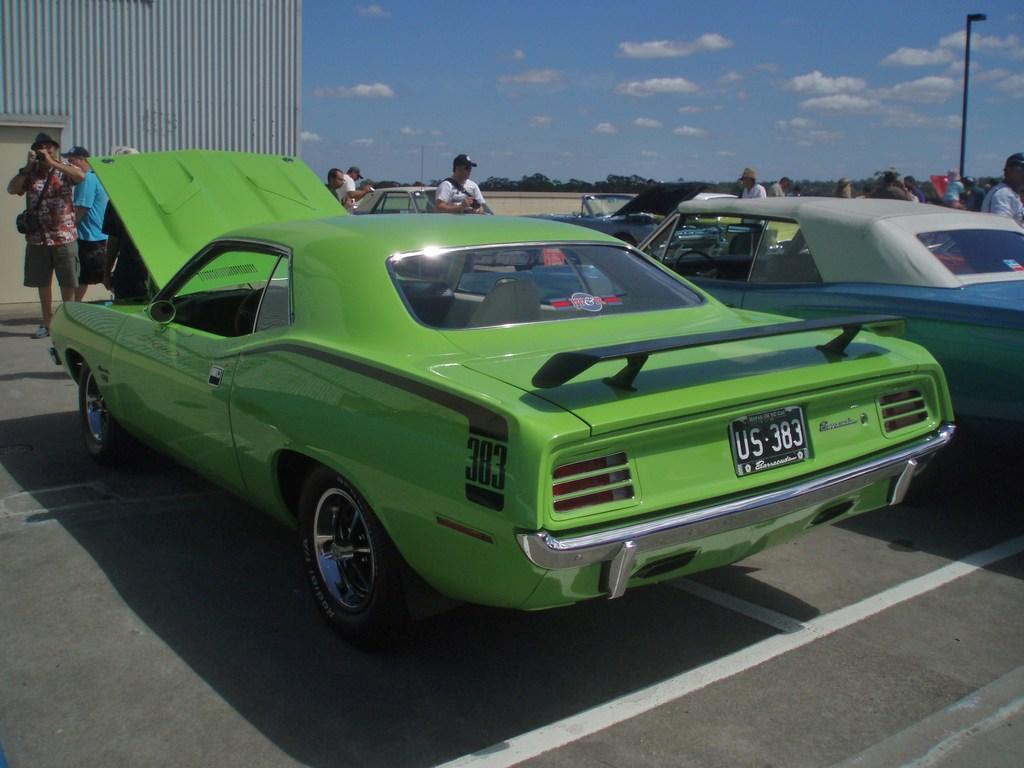Please provide a concise description of this image. In this picture I can see few cars parked and I can see bonnet of a car is opened and few people are standing and few wore caps on their heads and I can see a building on the top left corner and I can see trees and a pole light and I can see blue cloudy sky. 